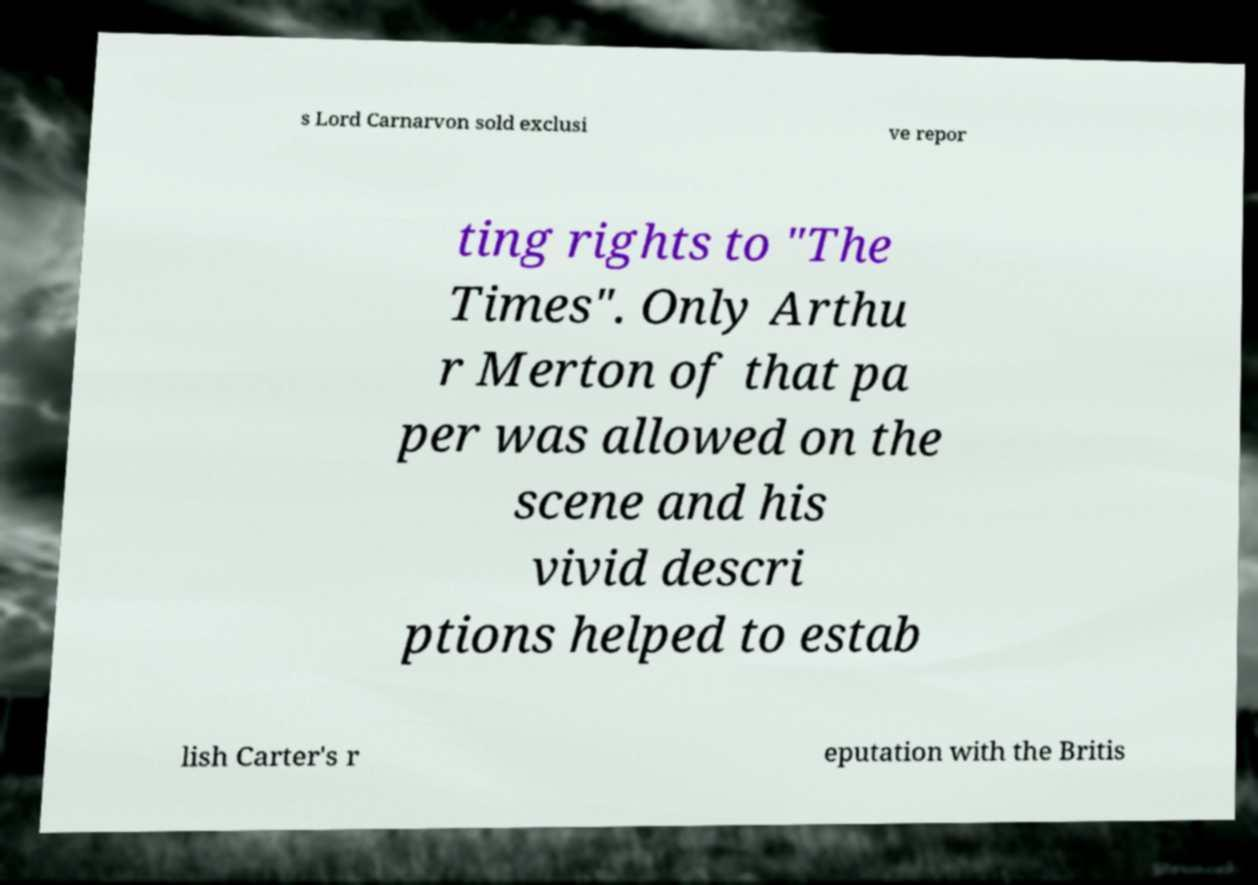I need the written content from this picture converted into text. Can you do that? s Lord Carnarvon sold exclusi ve repor ting rights to "The Times". Only Arthu r Merton of that pa per was allowed on the scene and his vivid descri ptions helped to estab lish Carter's r eputation with the Britis 